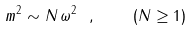Convert formula to latex. <formula><loc_0><loc_0><loc_500><loc_500>m ^ { 2 } \sim N \, \omega ^ { 2 } \ , \quad ( N \geq 1 )</formula> 